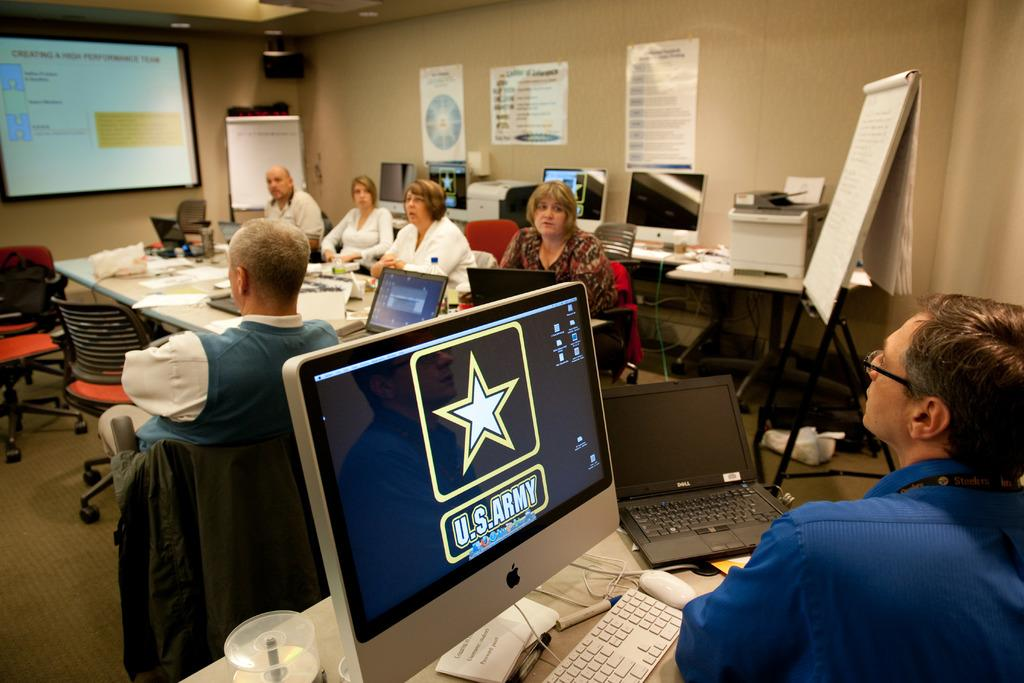<image>
Describe the image concisely. People are watching a presentation, and the person at the back of the room has a U.S. Army background on his computer monitor. 